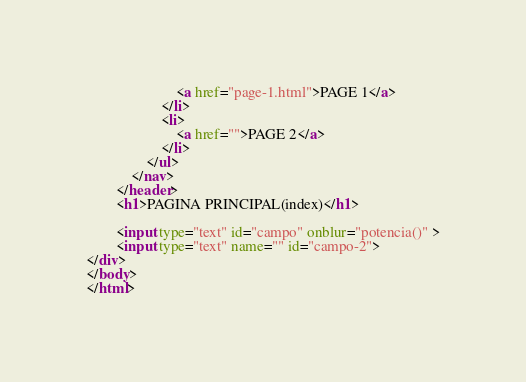Convert code to text. <code><loc_0><loc_0><loc_500><loc_500><_HTML_>                        <a href="page-1.html">PAGE 1</a>
                    </li>
                    <li>
                        <a href="">PAGE 2</a>
                    </li>
                </ul>
            </nav>
        </header>
        <h1>PAGINA PRINCIPAL(index)</h1>

        <input type="text" id="campo" onblur="potencia()" >
        <input type="text" name="" id="campo-2">
</div>
</body>
</html>
</code> 